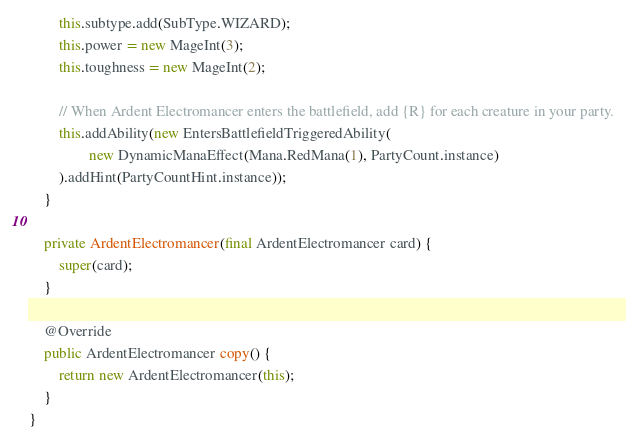Convert code to text. <code><loc_0><loc_0><loc_500><loc_500><_Java_>        this.subtype.add(SubType.WIZARD);
        this.power = new MageInt(3);
        this.toughness = new MageInt(2);

        // When Ardent Electromancer enters the battlefield, add {R} for each creature in your party.
        this.addAbility(new EntersBattlefieldTriggeredAbility(
                new DynamicManaEffect(Mana.RedMana(1), PartyCount.instance)
        ).addHint(PartyCountHint.instance));
    }

    private ArdentElectromancer(final ArdentElectromancer card) {
        super(card);
    }

    @Override
    public ArdentElectromancer copy() {
        return new ArdentElectromancer(this);
    }
}
</code> 